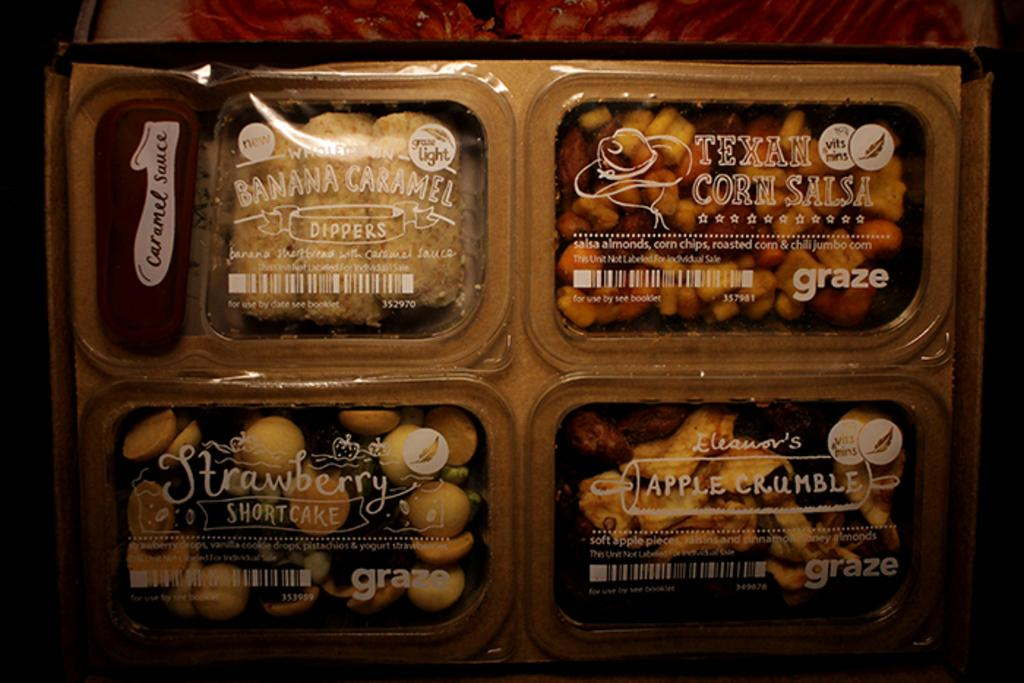What is inside the box that is visible in the image? There are food items packed in a box in the image. What information can be found on the top of the box? There is text on the top of the box. What object is located at the top of the box? There is an object at the top of the box. What historical event is depicted on the side of the box? There is no historical event depicted on the side of the box; the image only shows food items packed in a box with text and an object at the top. 